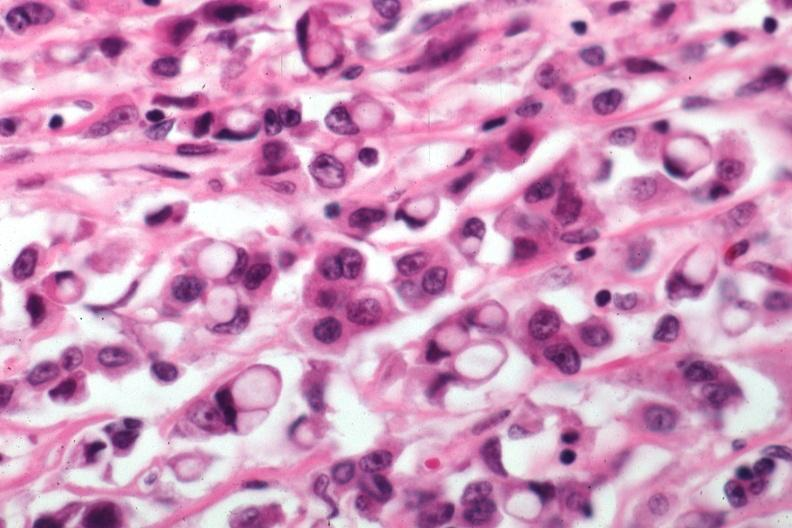s breast present?
Answer the question using a single word or phrase. Yes 